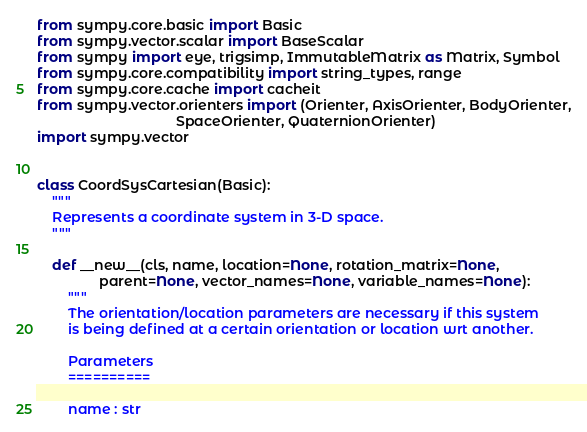Convert code to text. <code><loc_0><loc_0><loc_500><loc_500><_Python_>from sympy.core.basic import Basic
from sympy.vector.scalar import BaseScalar
from sympy import eye, trigsimp, ImmutableMatrix as Matrix, Symbol
from sympy.core.compatibility import string_types, range
from sympy.core.cache import cacheit
from sympy.vector.orienters import (Orienter, AxisOrienter, BodyOrienter,
                                    SpaceOrienter, QuaternionOrienter)
import sympy.vector


class CoordSysCartesian(Basic):
    """
    Represents a coordinate system in 3-D space.
    """

    def __new__(cls, name, location=None, rotation_matrix=None,
                parent=None, vector_names=None, variable_names=None):
        """
        The orientation/location parameters are necessary if this system
        is being defined at a certain orientation or location wrt another.

        Parameters
        ==========

        name : str</code> 